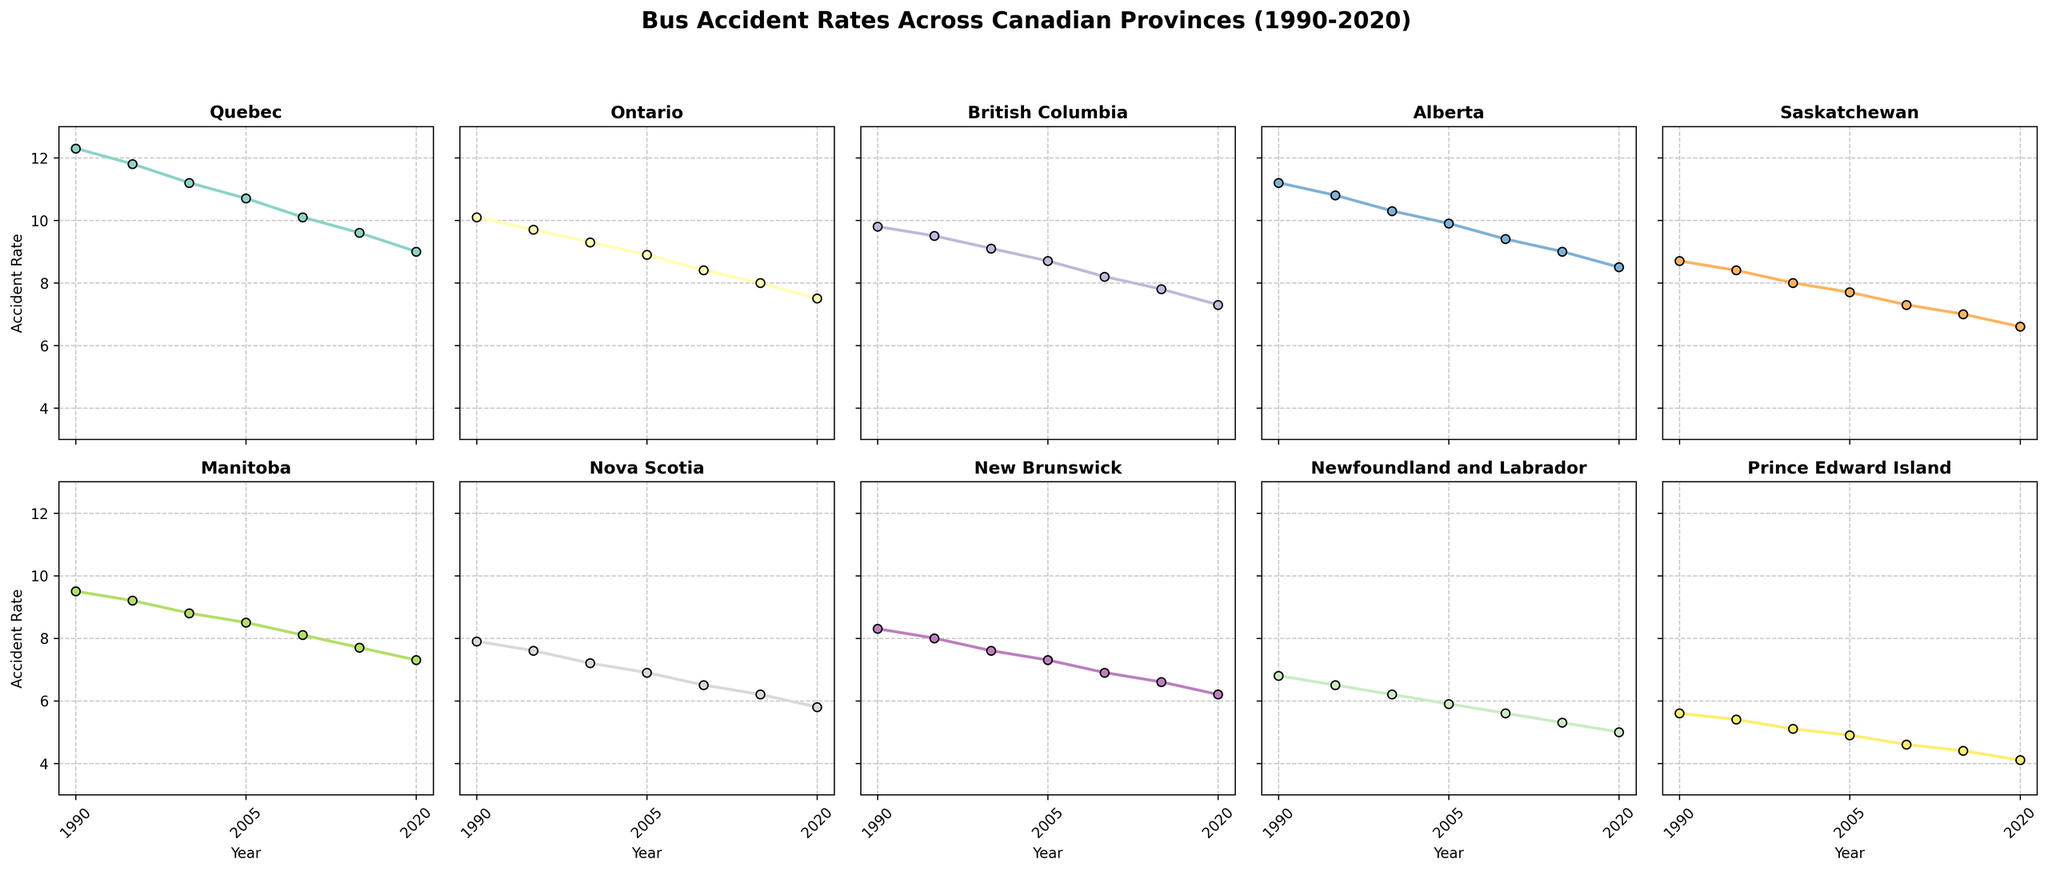What is the trend of bus accident rates in Quebec from 1990 to 2020? By observing the graph for Quebec, you will notice that the accident rate starts at 12.3 in 1990 and decreases consistently over the years, reaching 9.0 in 2020.
Answer: Decreasing Which province had the lowest bus accident rate in 2020? By looking at the graphs for 2020 across all provinces, Prince Edward Island has the lowest bus accident rate at 4.1.
Answer: Prince Edward Island In which year did Alberta and Manitoba have the same bus accident rate? By observing the graphs for Alberta and Manitoba, you can see that both provinces have a bus accident rate of 8.5 in 2005.
Answer: 2005 How does the trend of bus accident rates in Ontario compare to British Columbia from 1990 to 2020? From the graphs, Ontario shows a consistent decrease in bus accident rates from 10.1 in 1990 to 7.5 in 2020. For British Columbia, the rates also decrease consistently from 9.8 in 1990 to 7.3 in 2020. Both provinces show a downward trend in bus accident rates over time.
Answer: Both provinces show a downward trend Which province had a larger drop in bus accident rate from 1990 to 2020, Nova Scotia or Manitoba? For Nova Scotia, the bus accident rate drops from 7.9 in 1990 to 5.8 in 2020, a difference of 2.1. For Manitoba, it drops from 9.5 in 1990 to 7.3 in 2020, a difference of 2.2. Therefore, Manitoba had a slightly larger drop in bus accident rate.
Answer: Manitoba What is the average bus accident rate in Saskatchewan over the given years? The bus accident rates for Saskatchewan are 8.7 (1990), 8.4 (1995), 8.0 (2000), 7.7 (2005), 7.3 (2010), 7.0 (2015), and 6.6 (2020). Summing these gives 53.7, and dividing by 7 (number of data points) gives an average rate of approximately 7.67.
Answer: 7.67 In which year did Quebec have its sharpest decline in bus accident rates? By examining the graph for Quebec, the sharpest decline appears between 1990 (12.3) and 1995 (11.8), a difference of 0.5. However, the largest one-year drop is from 2005 (10.7) to 2010 (10.1), a difference of 0.6. Thus, the sharpest one-year decline is between 2005 and 2010.
Answer: 2005 to 2010 Compare the bus accident rates in 2010 for Alberta and Newfoundland and Labrador. Which one is higher? Looking at the graphs for 2010, Alberta has a rate of 9.4 while Newfoundland and Labrador have a rate of 5.6. Therefore, Alberta's rate is higher.
Answer: Alberta What is the difference in bus accident rates between the highest and lowest provinces in 1990? In 1990, Quebec has the highest rate at 12.3 and Prince Edward Island has the lowest at 5.6. The difference is 12.3 - 5.6 = 6.7.
Answer: 6.7 